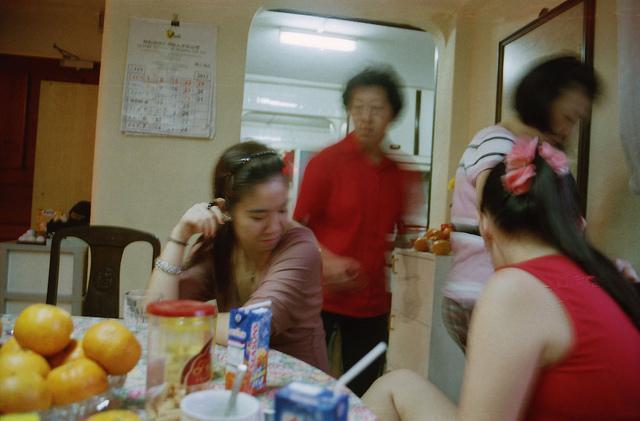How many women are in the picture?
Give a very brief answer. 4. How many people in the photo?
Give a very brief answer. 4. How many people are in this picture completely?
Give a very brief answer. 4. How many glasses are on the table?
Give a very brief answer. 1. How many oranges are in the photo?
Give a very brief answer. 4. How many people are in the picture?
Give a very brief answer. 4. 